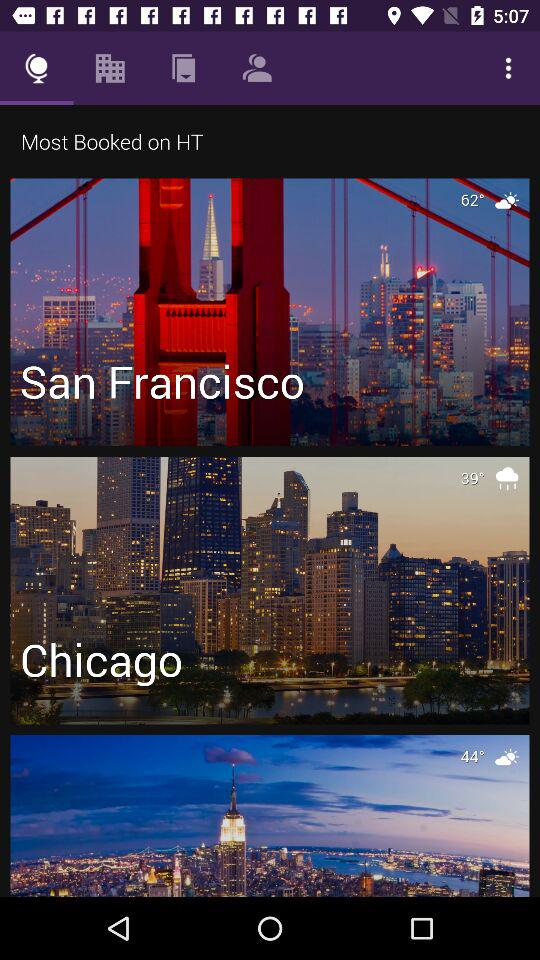How many degrees warmer is the temperature in Chicago than in the last item?
Answer the question using a single word or phrase. 5 